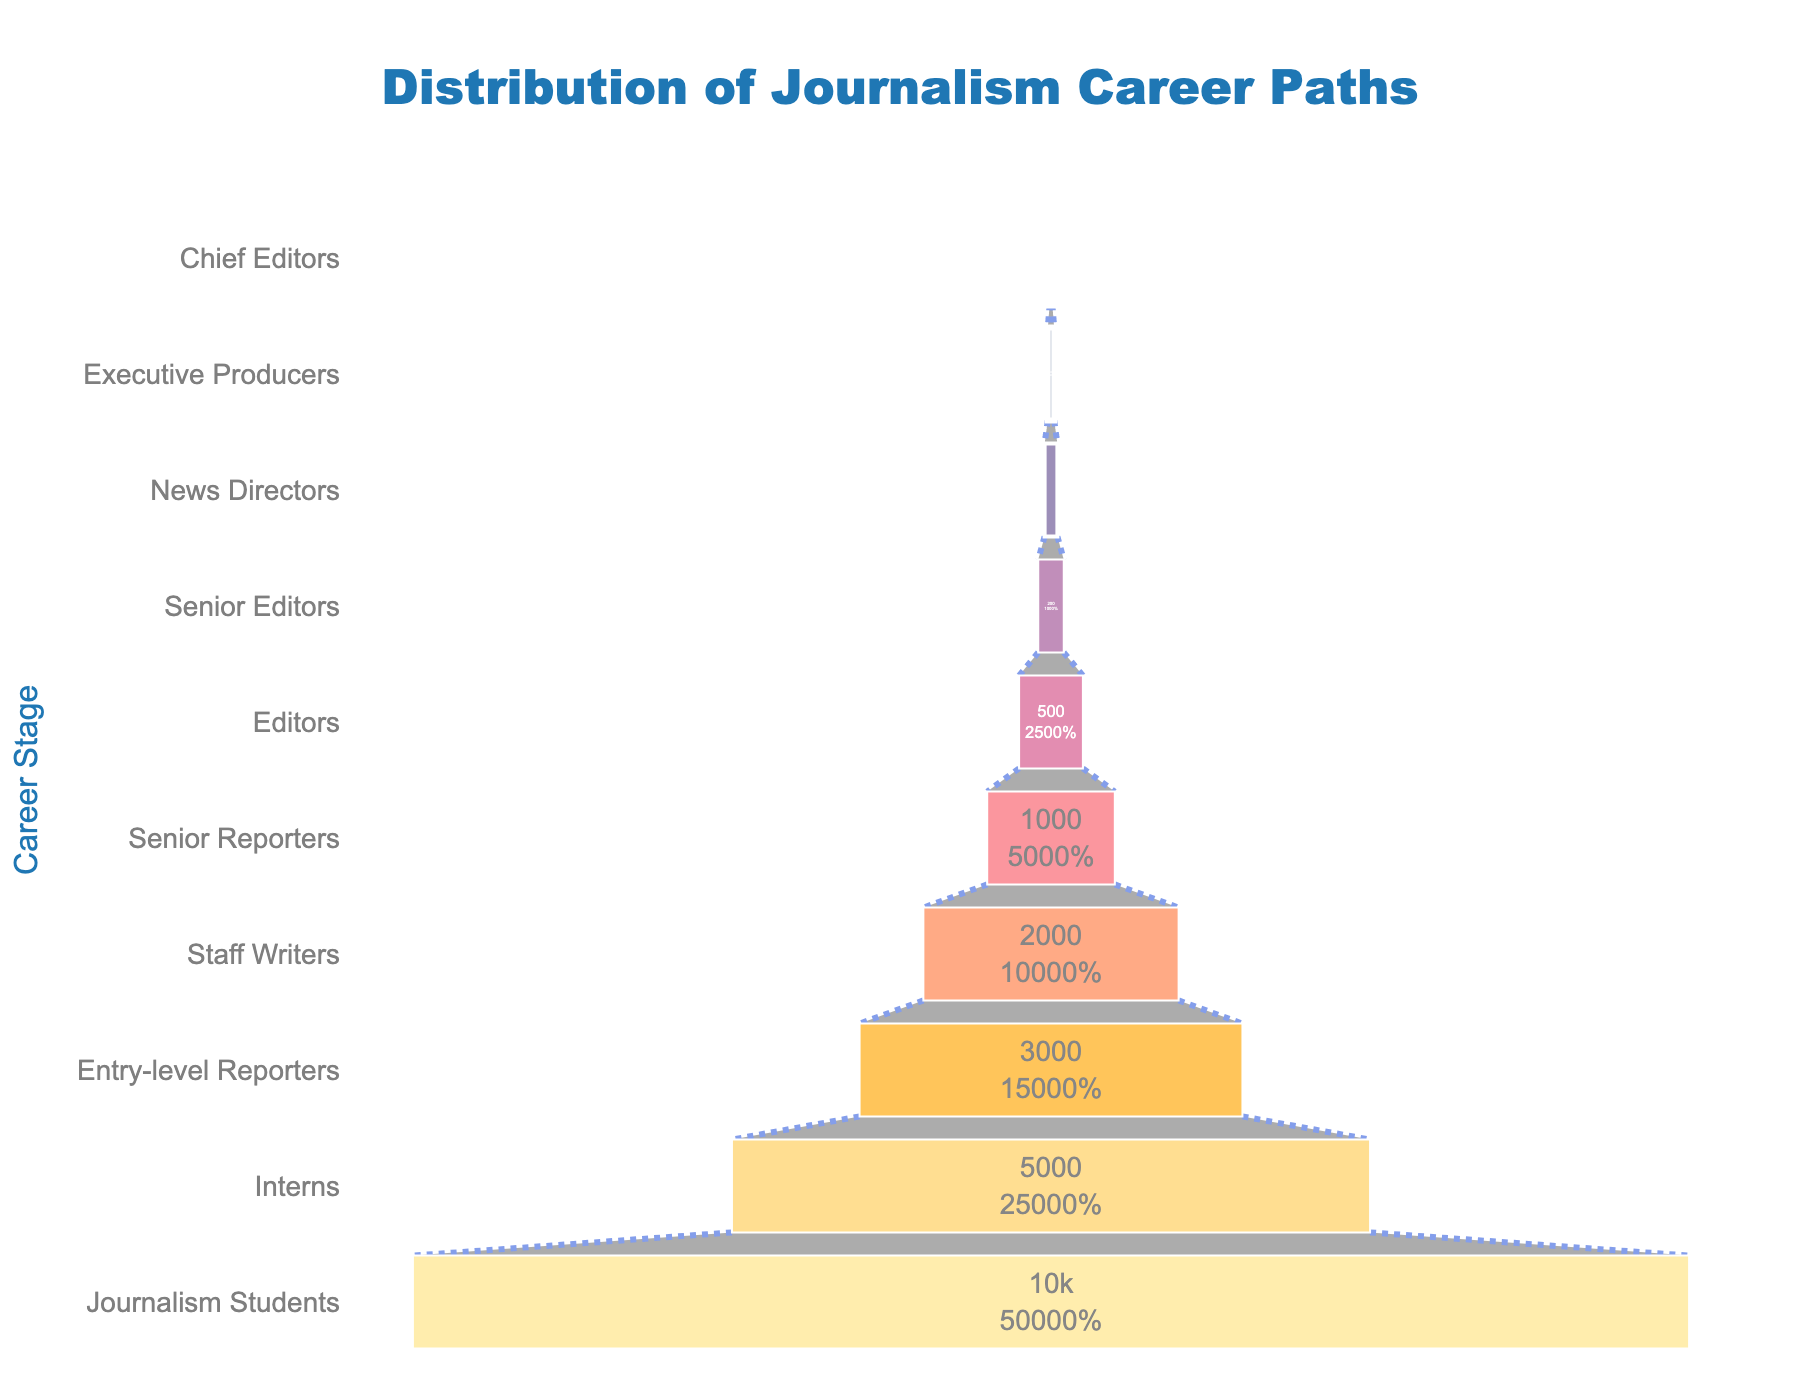What's the title of the funnel chart? The title is located at the top center of the funnel chart. It is typically larger in font size and bolder compared to other text.
Answer: Distribution of Journalism Career Paths How many journalism students are shown in the chart? The number of journalism students is shown in the widest section at the bottom of the funnel chart.
Answer: 10000 At which career stage does the number of journalists drop below 1000? Locate the stage where the funnel segment's labeled number is below 1000. This information is displayed on the funnel segments.
Answer: Senior Reporters What is the percentage of interns compared to journalism students? First, find the number of interns and journalism students from the funnel chart's labels. Then, calculate the percentage by dividing the number of interns by the number of journalism students and multiplying by 100. (5000/10000) * 100 = 50%
Answer: 50% How does the number of entry-level reporters compare to staff writers? Compare the numbers next to the "Entry-level Reporters" and "Staff Writers" segments on the chart.
Answer: Entry-level Reporters are more than Staff Writers Which stage in the funnel has half the number of the previous stage? Identify the stages where the number of journalists is approximately half of the number at the preceding stage by comparing successively listed counts.
Answer: Editors have half the number of Senior Reporters What stage comes immediately before 'News Directors' in terms of career paths? Track the sequence of stages moving upward within the funnel until reaching the one immediately below 'News Directors'.
Answer: Senior Editors How many journalists are there at the 'Chief Editors' stage? The number of journalists at any stage is indicated within the funnel segment corresponding to that stage.
Answer: 20 What is the ratio of executive producers to senior editors? Divide the number of executive producers by the number of senior editors as indicated in the funnel chart. 50/200 = 0.25
Answer: 0.25 At which level is the first dramatic drop in the number of journalists observed? Look for the largest visible drop between adjacent stages on the funnel chart. This can be observed by comparing each stage proportionally.
Answer: Between Journalism Students and Interns 